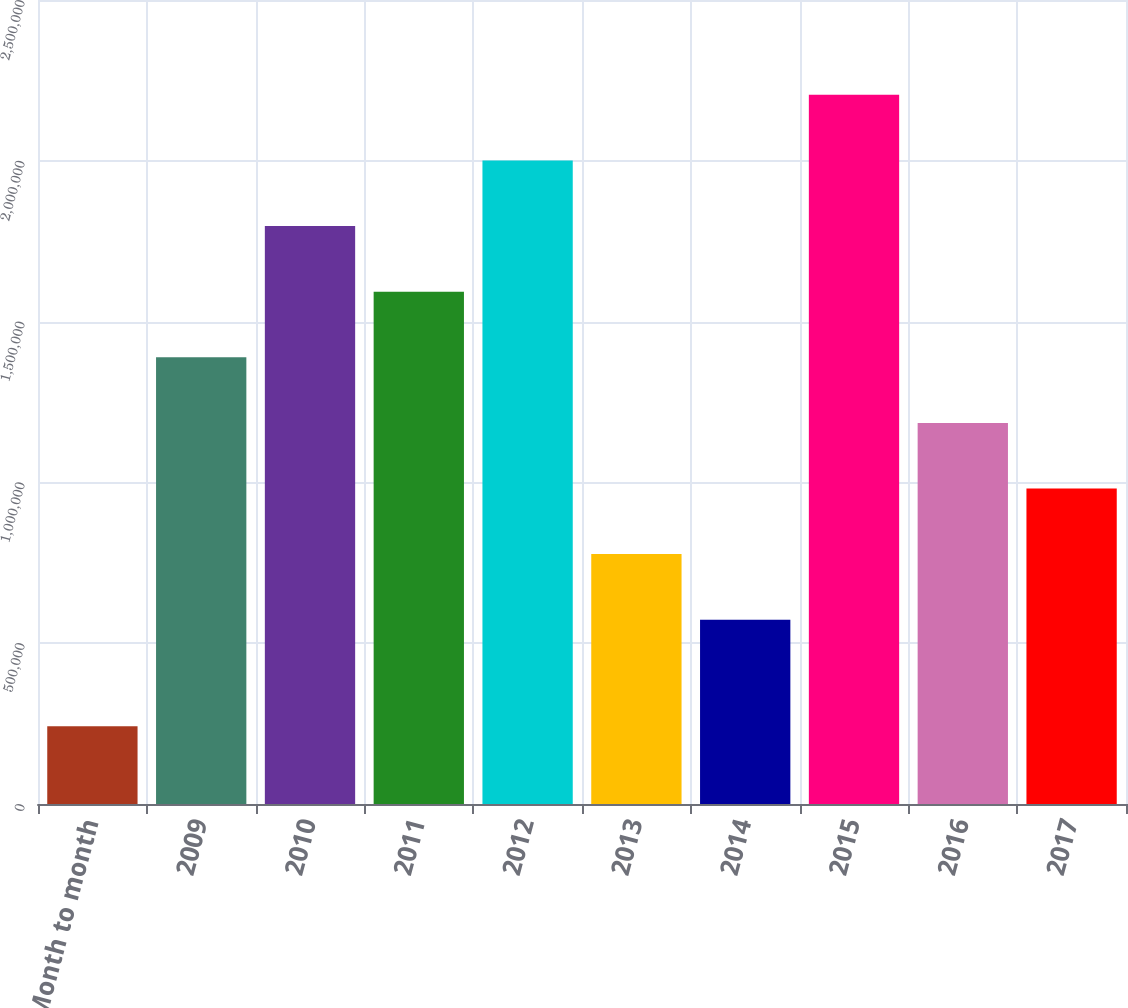Convert chart. <chart><loc_0><loc_0><loc_500><loc_500><bar_chart><fcel>Month to month<fcel>2009<fcel>2010<fcel>2011<fcel>2012<fcel>2013<fcel>2014<fcel>2015<fcel>2016<fcel>2017<nl><fcel>242000<fcel>1.389e+06<fcel>1.797e+06<fcel>1.593e+06<fcel>2.001e+06<fcel>777000<fcel>573000<fcel>2.205e+06<fcel>1.185e+06<fcel>981000<nl></chart> 